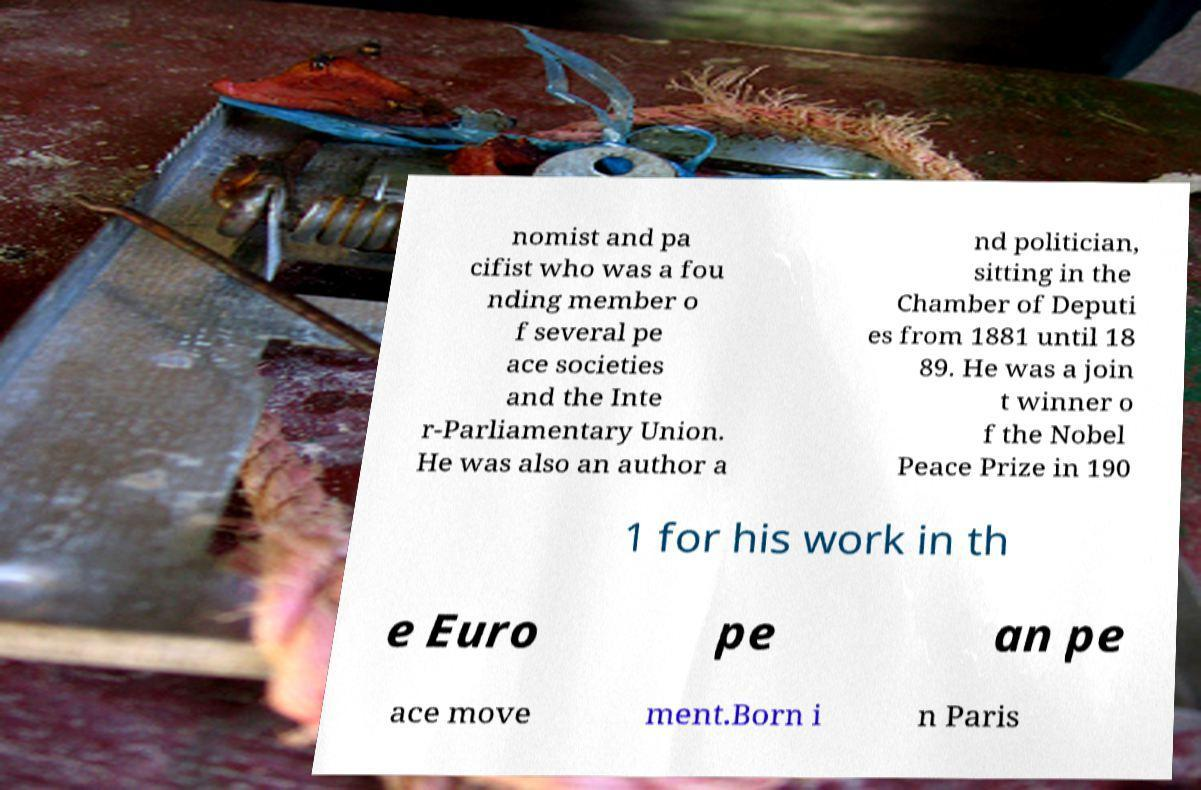Please identify and transcribe the text found in this image. nomist and pa cifist who was a fou nding member o f several pe ace societies and the Inte r-Parliamentary Union. He was also an author a nd politician, sitting in the Chamber of Deputi es from 1881 until 18 89. He was a join t winner o f the Nobel Peace Prize in 190 1 for his work in th e Euro pe an pe ace move ment.Born i n Paris 